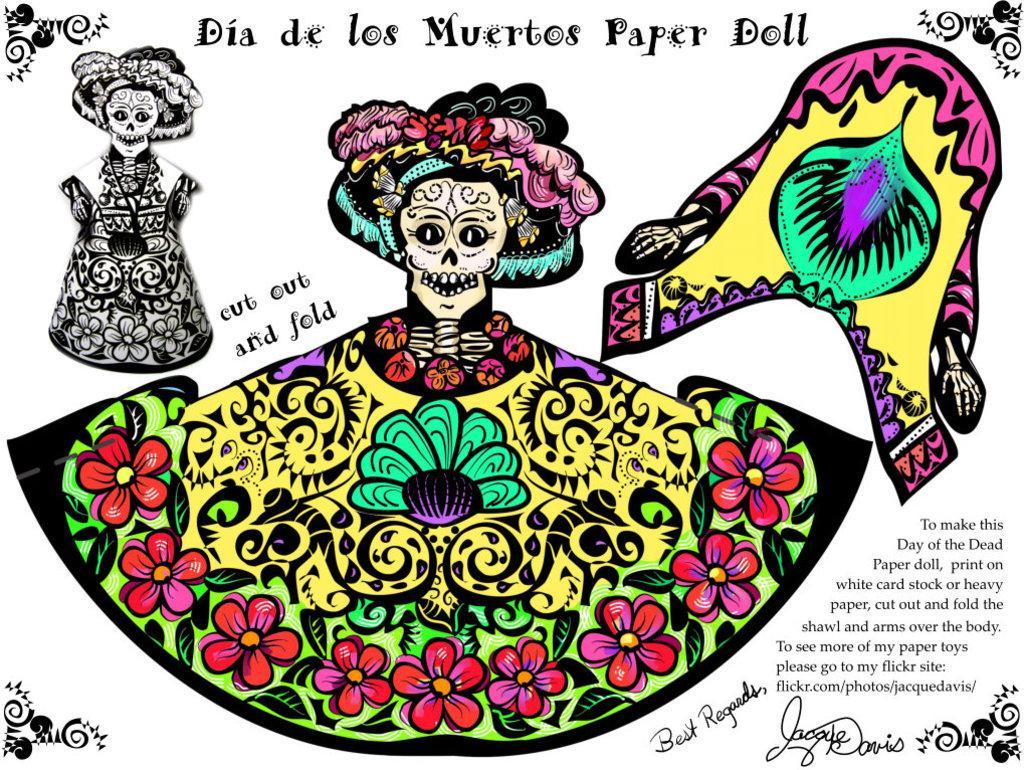In one or two sentences, can you explain what this image depicts? This is a painting, in this image there are some toys and at the bottom and on the top there is some text. 